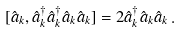Convert formula to latex. <formula><loc_0><loc_0><loc_500><loc_500>[ \hat { a } _ { k } , \hat { a } ^ { \dagger } _ { k } \hat { a } ^ { \dagger } _ { k } \hat { a } _ { k } \hat { a } _ { k } ] = 2 \hat { a } ^ { \dagger } _ { k } \hat { a } _ { k } \hat { a } _ { k } \, .</formula> 